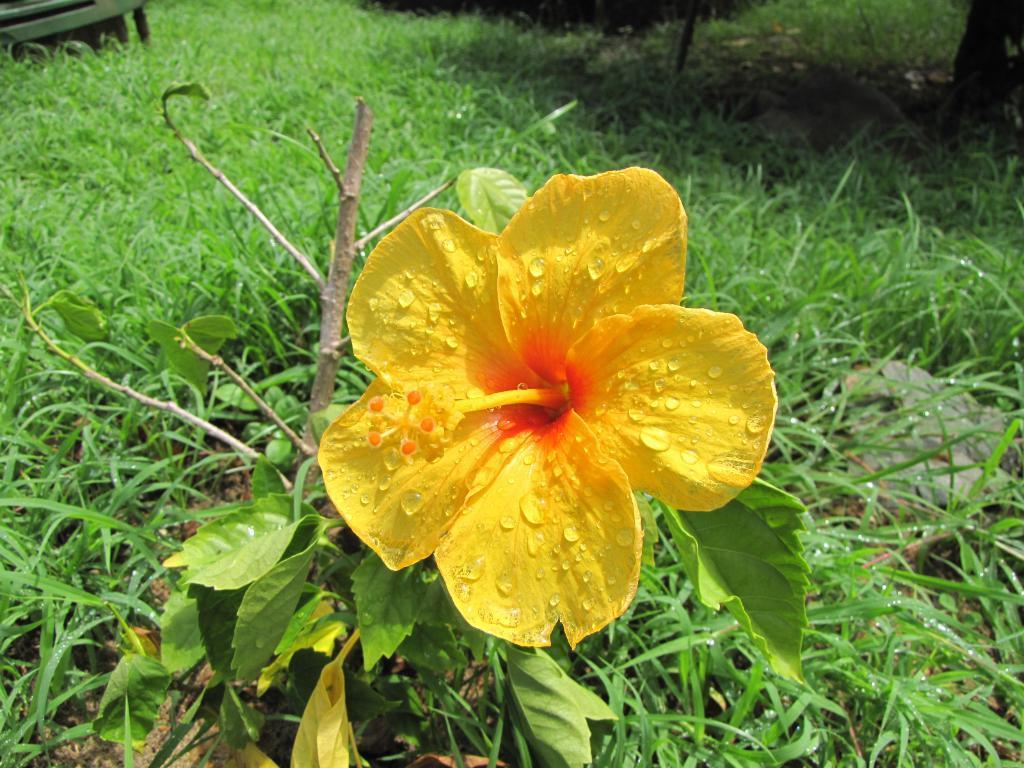In one or two sentences, can you explain what this image depicts? In this picture we can see a flower and in the background we can see grass. 